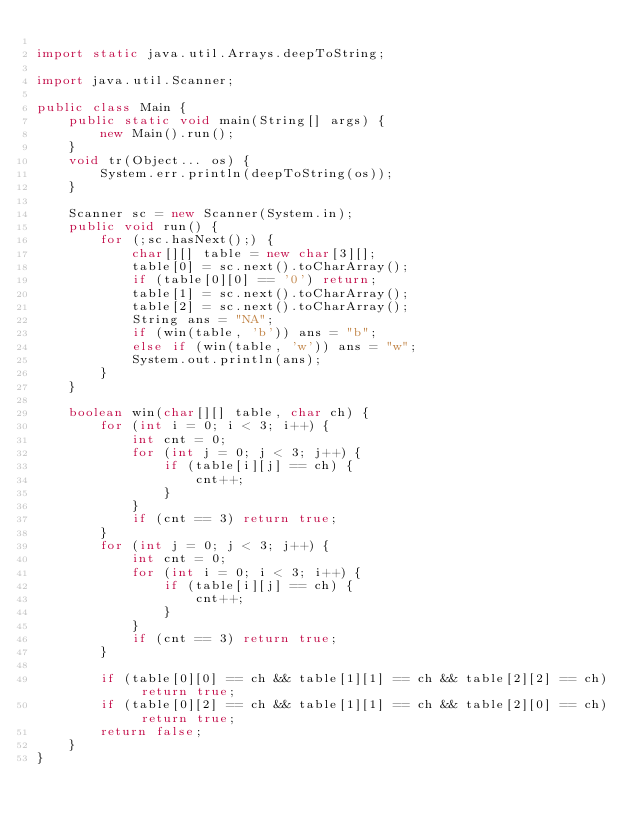Convert code to text. <code><loc_0><loc_0><loc_500><loc_500><_Java_>
import static java.util.Arrays.deepToString;

import java.util.Scanner;

public class Main {
	public static void main(String[] args) {
		new Main().run();
	}
	void tr(Object... os) {
		System.err.println(deepToString(os));
	}

	Scanner sc = new Scanner(System.in);
	public void run() {
		for (;sc.hasNext();) {
			char[][] table = new char[3][];
			table[0] = sc.next().toCharArray();
			if (table[0][0] == '0') return;
			table[1] = sc.next().toCharArray();
			table[2] = sc.next().toCharArray();
			String ans = "NA";
			if (win(table, 'b')) ans = "b";
			else if (win(table, 'w')) ans = "w";
			System.out.println(ans);
		}
	}
	
	boolean win(char[][] table, char ch) {
		for (int i = 0; i < 3; i++) {
			int cnt = 0;
			for (int j = 0; j < 3; j++) {
				if (table[i][j] == ch) {
					cnt++;
				}
			}
			if (cnt == 3) return true;
		}
		for (int j = 0; j < 3; j++) {
			int cnt = 0;
			for (int i = 0; i < 3; i++) {
				if (table[i][j] == ch) {
					cnt++;
				}
			}
			if (cnt == 3) return true;
		}
		
		if (table[0][0] == ch && table[1][1] == ch && table[2][2] == ch) return true;
		if (table[0][2] == ch && table[1][1] == ch && table[2][0] == ch) return true;
		return false;
	}
}</code> 